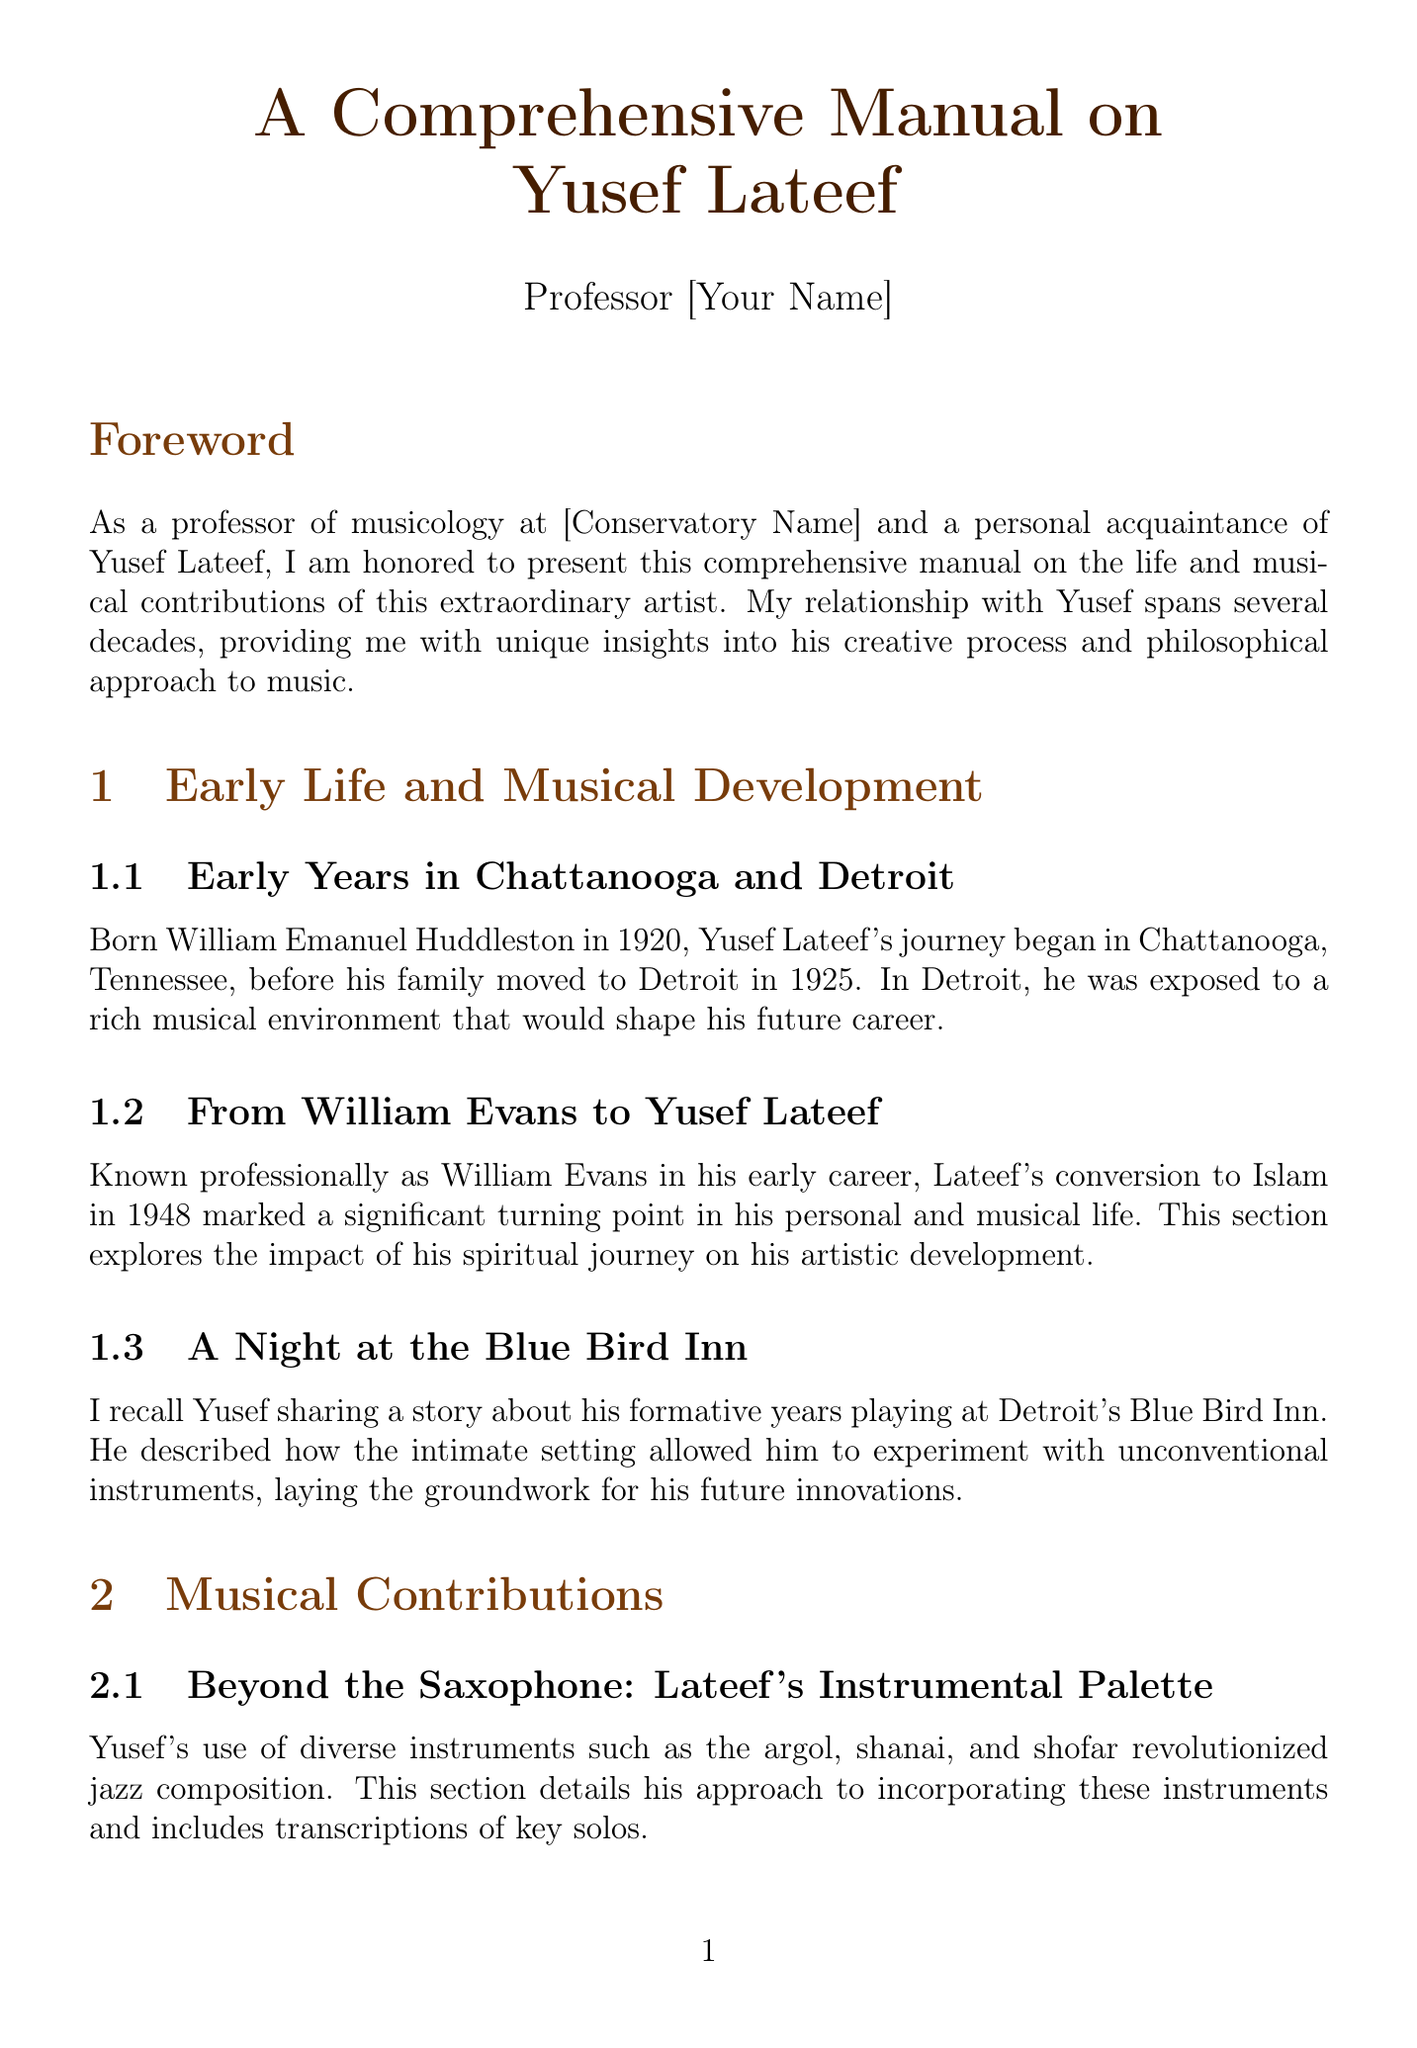What year was Yusef Lateef born? The document states that Yusef Lateef was born in 1920.
Answer: 1920 What was Yusef Lateef's birth name? The document mentions that Yusef Lateef was born William Emanuel Huddleston.
Answer: William Emanuel Huddleston In what city did Yusef Lateef grow up? The document indicates that he moved to Detroit in 1925 and spent his formative years there.
Answer: Detroit What is the title of Yusef Lateef's concept of music? The document references the concept as 'autophysiopsychic' music.
Answer: autophysiopsychic What instrument did Yusef Lateef commonly play? The document notes that he is well-known for his work with the saxophone, among other instruments.
Answer: saxophone When did Lateef convert to Islam? The document states that Yusef Lateef converted to Islam in 1948.
Answer: 1948 What is the name of one of Lateef's significant albums? The document mentions seminal albums such as 'Eastern Sounds'.
Answer: Eastern Sounds Which university did Lateef teach at? The document states he had a tenure at the University of Massachusetts Amherst.
Answer: University of Massachusetts Amherst What type of music does Yusef Lateef's philosophy incorporate? The document indicates that it includes elements from jazz.
Answer: jazz 